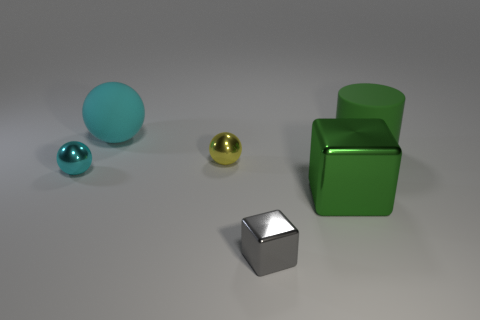The yellow metal thing that is the same shape as the cyan matte thing is what size?
Keep it short and to the point. Small. Are there any other things that are the same size as the green rubber thing?
Your response must be concise. Yes. What number of other objects are the same color as the cylinder?
Your answer should be compact. 1. What number of cubes are matte things or tiny blue objects?
Ensure brevity in your answer.  0. There is a shiny sphere left of the large thing that is on the left side of the large metallic cube; what is its color?
Your answer should be compact. Cyan. The tiny gray metal object has what shape?
Ensure brevity in your answer.  Cube. There is a matte object behind the green rubber thing; does it have the same size as the small cyan object?
Offer a very short reply. No. Are there any big yellow things made of the same material as the cylinder?
Offer a very short reply. No. What number of objects are either yellow metallic balls that are in front of the big cyan object or large shiny things?
Provide a succinct answer. 2. Are any big shiny blocks visible?
Provide a short and direct response. Yes. 